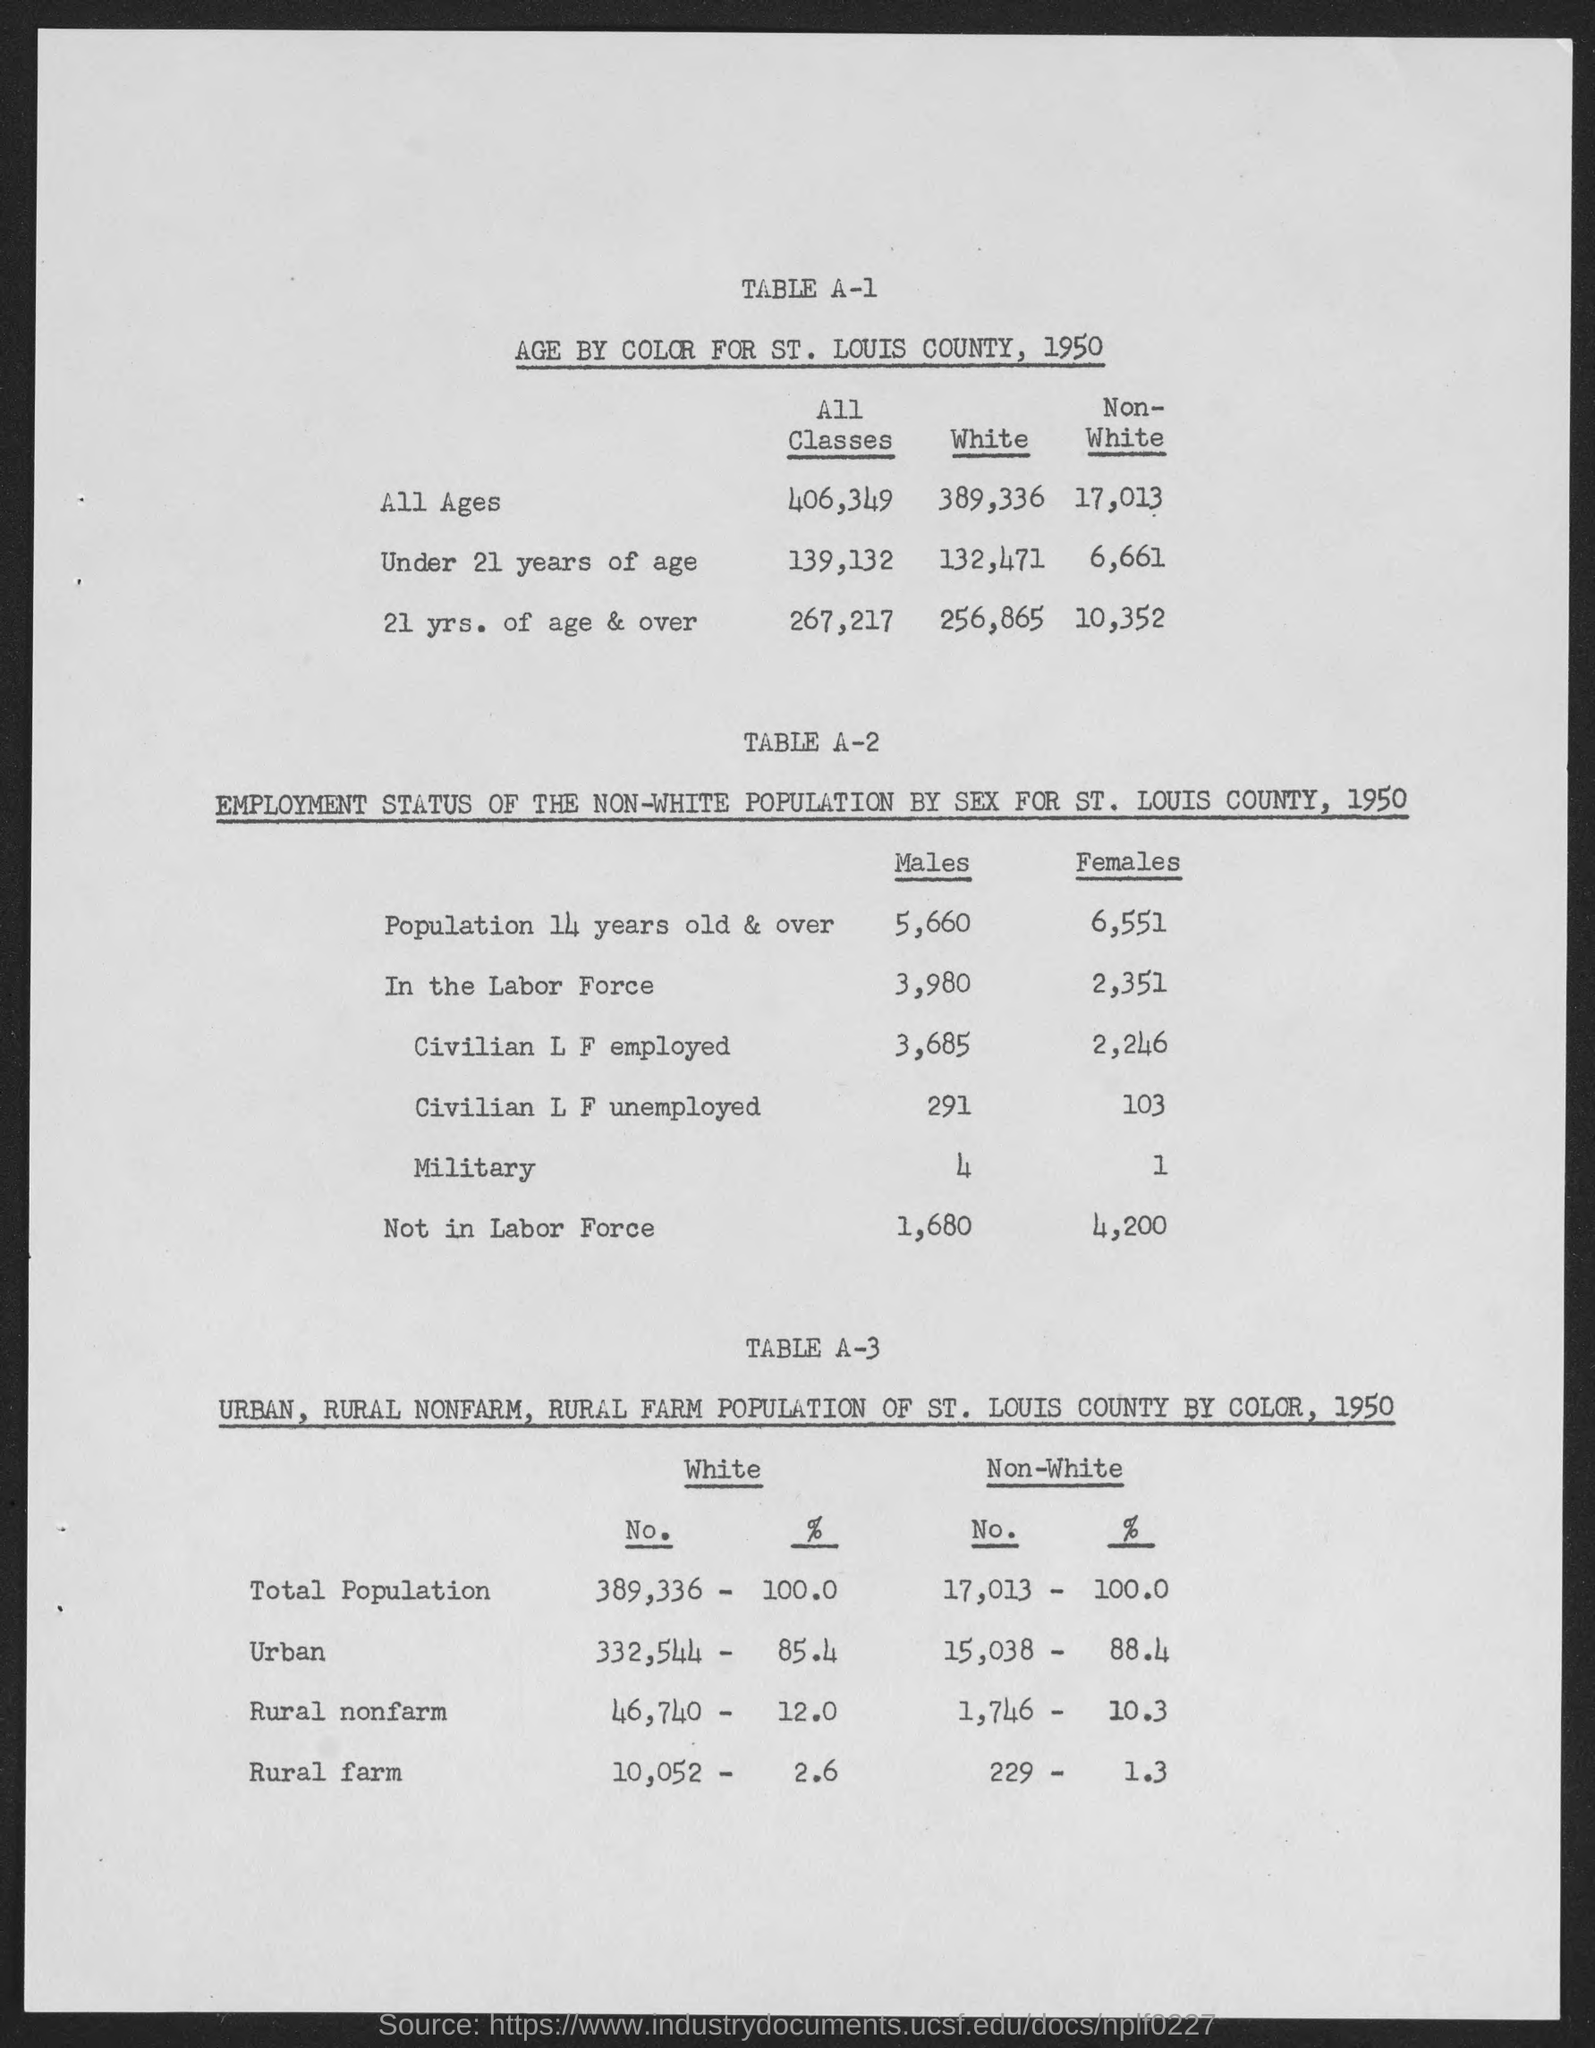What is the age by color for St. Louis county, 1950 for under 21 years of age for all classes? In St. Louis County, 1950, the population under 21 years of age was 139,132 across all classes. This figure includes 132,471 individuals identified as White and 6,661 individuals identified as Non-White. 